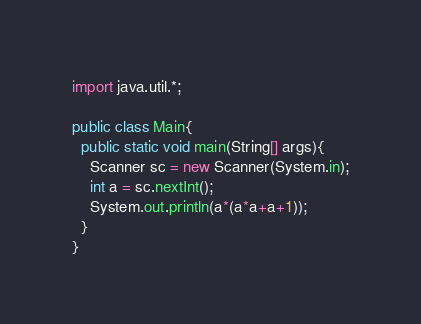<code> <loc_0><loc_0><loc_500><loc_500><_Java_>import java.util.*;

public class Main{
  public static void main(String[] args){
    Scanner sc = new Scanner(System.in);
    int a = sc.nextInt();
    System.out.println(a*(a*a+a+1));
  }
}
</code> 